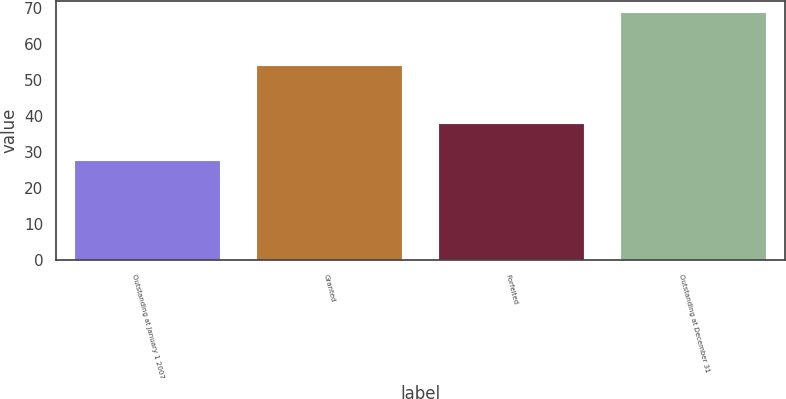<chart> <loc_0><loc_0><loc_500><loc_500><bar_chart><fcel>Outstanding at January 1 2007<fcel>Granted<fcel>Forfeited<fcel>Outstanding at December 31<nl><fcel>27.68<fcel>53.92<fcel>37.76<fcel>68.61<nl></chart> 